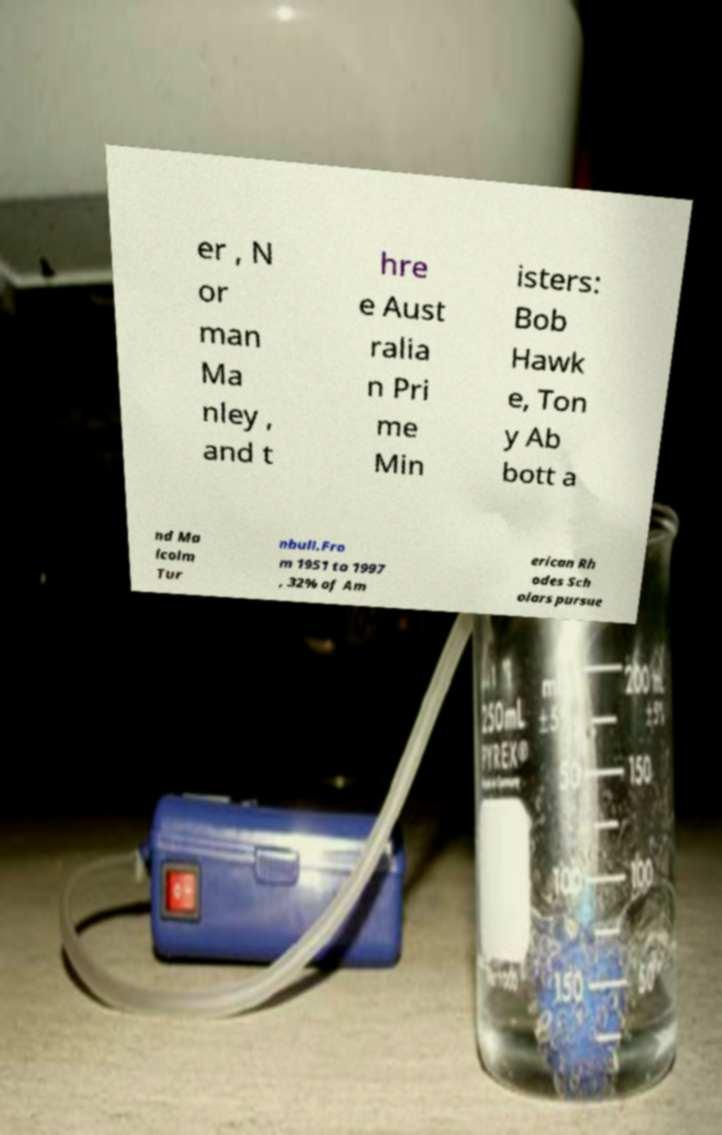Could you assist in decoding the text presented in this image and type it out clearly? er , N or man Ma nley , and t hre e Aust ralia n Pri me Min isters: Bob Hawk e, Ton y Ab bott a nd Ma lcolm Tur nbull.Fro m 1951 to 1997 , 32% of Am erican Rh odes Sch olars pursue 